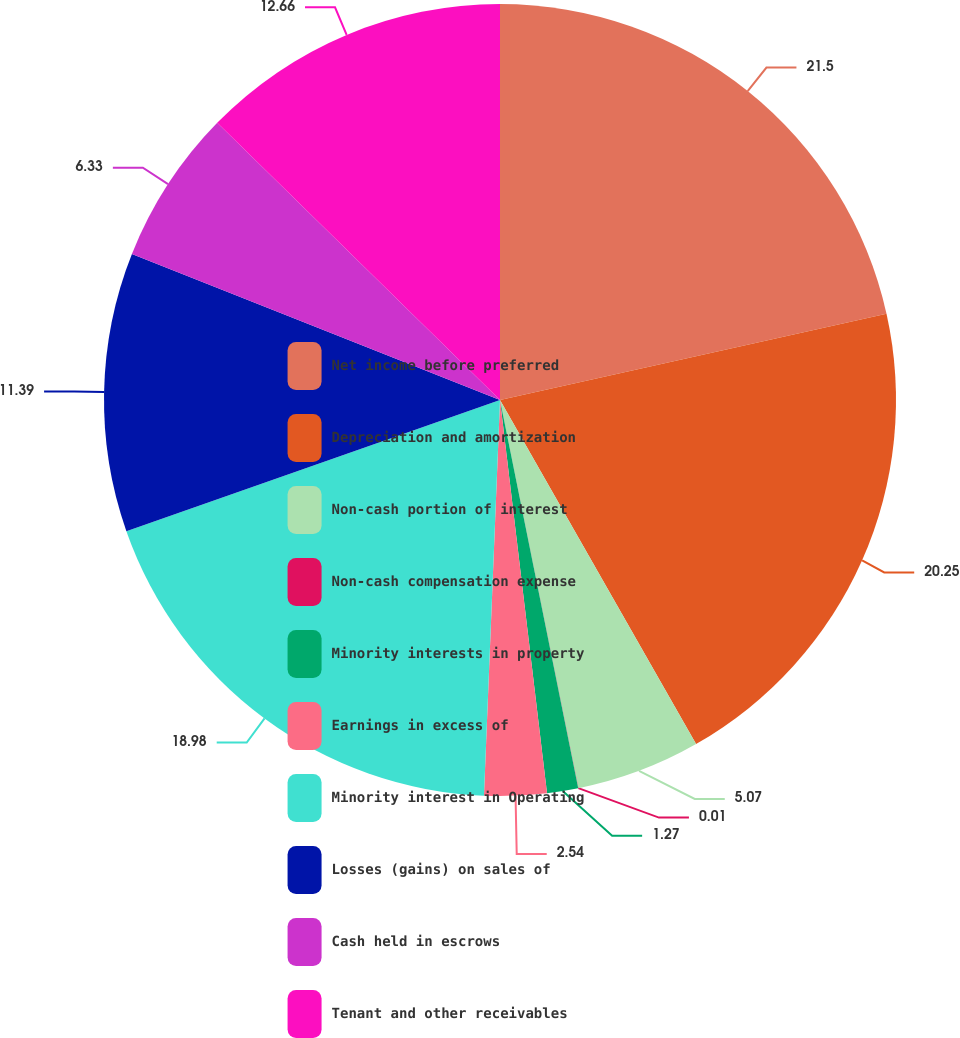<chart> <loc_0><loc_0><loc_500><loc_500><pie_chart><fcel>Net income before preferred<fcel>Depreciation and amortization<fcel>Non-cash portion of interest<fcel>Non-cash compensation expense<fcel>Minority interests in property<fcel>Earnings in excess of<fcel>Minority interest in Operating<fcel>Losses (gains) on sales of<fcel>Cash held in escrows<fcel>Tenant and other receivables<nl><fcel>21.51%<fcel>20.25%<fcel>5.07%<fcel>0.01%<fcel>1.27%<fcel>2.54%<fcel>18.98%<fcel>11.39%<fcel>6.33%<fcel>12.66%<nl></chart> 